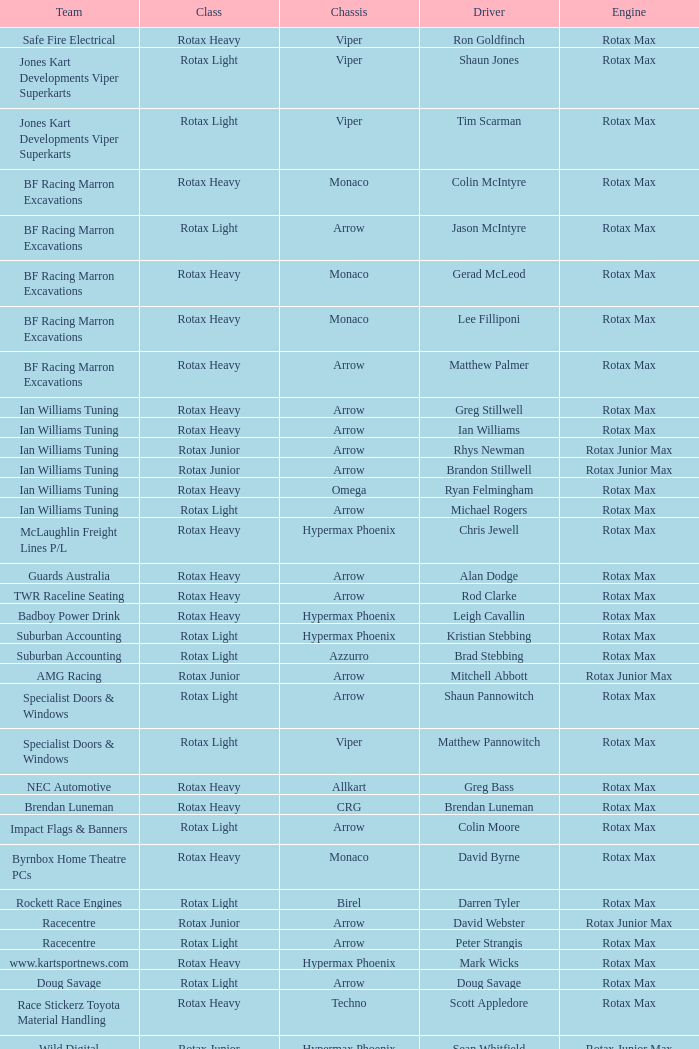What type of engine does the BF Racing Marron Excavations have that also has Monaco as chassis and Lee Filliponi as the driver? Rotax Max. 